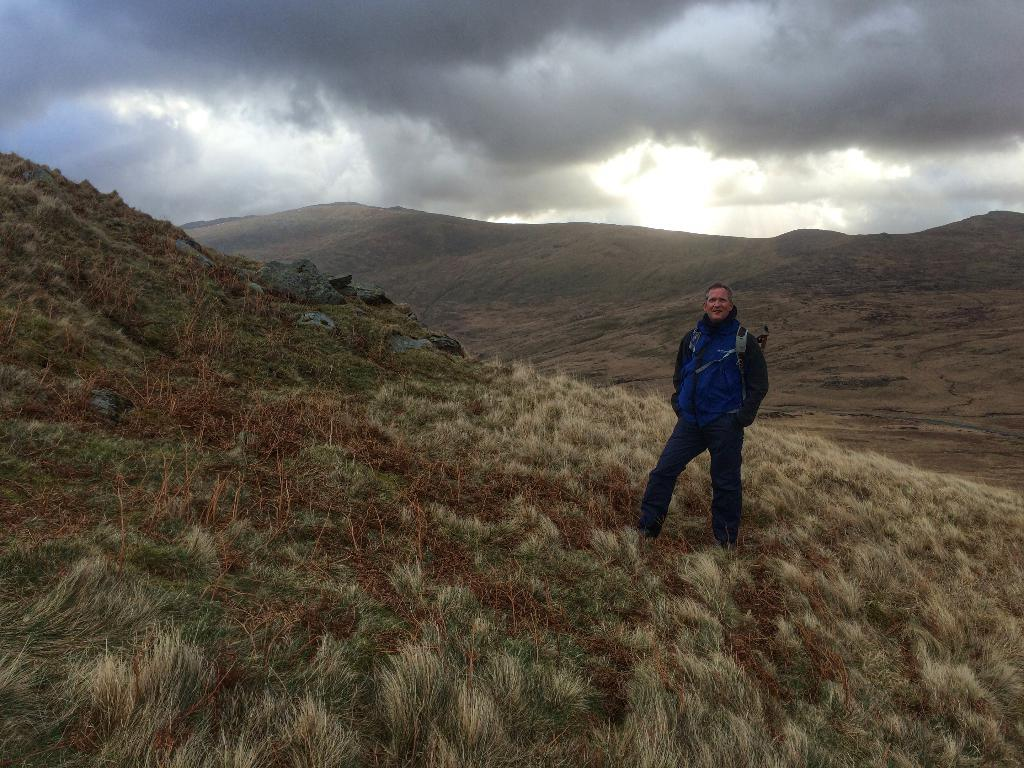What is the main subject of the image? There is a person standing in the image. What type of terrain is visible in the image? There is grass in the image. What can be seen in the distance in the image? There are hills in the background of the image. What is visible above the hills in the image? The sky is visible in the background of the image. What type of stick can be seen in the person's hand in the image? There is no stick present in the person's hand or in the image. How many beads are visible on the person's necklace in the image? There is no necklace or beads present in the image. 